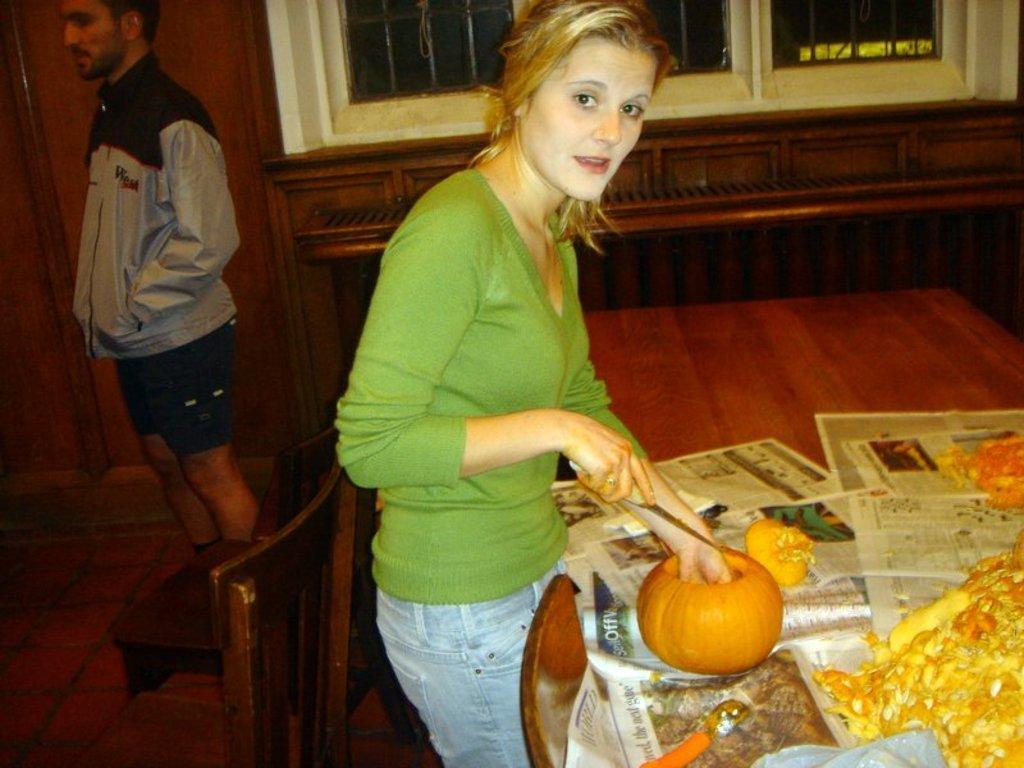Describe this image in one or two sentences. In this image, we can see a table, on that table there are some newspapers, there is a woman standing, she is holding a knife, at the left side there is a man standing and there are some chairs, at the background there are some white color windows. 